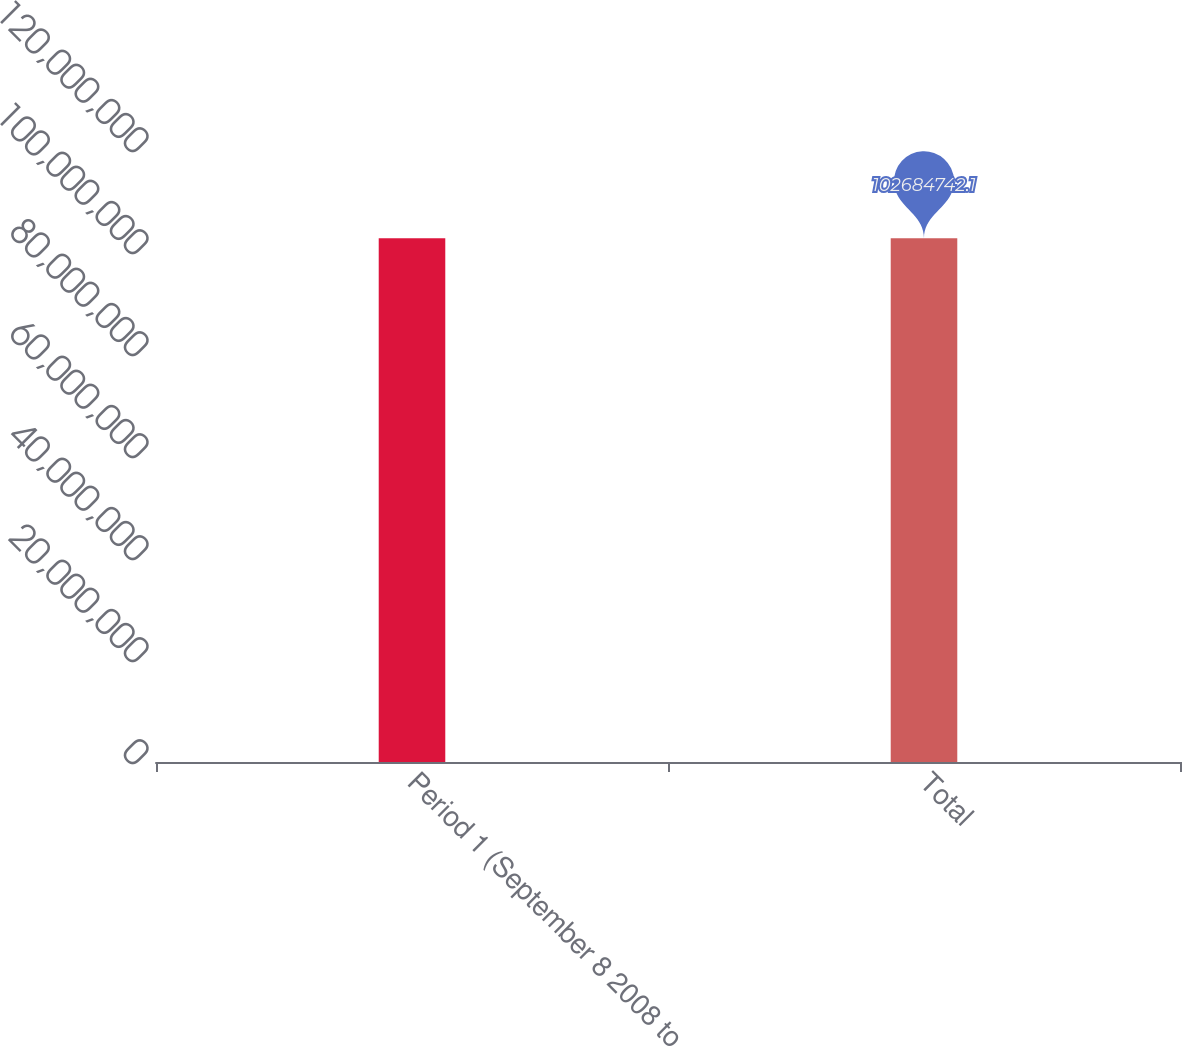Convert chart. <chart><loc_0><loc_0><loc_500><loc_500><bar_chart><fcel>Period 1 (September 8 2008 to<fcel>Total<nl><fcel>1.02685e+08<fcel>1.02685e+08<nl></chart> 